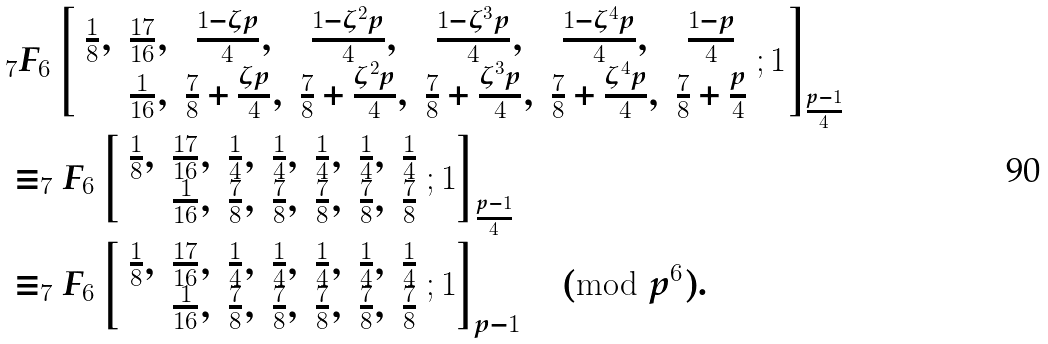Convert formula to latex. <formula><loc_0><loc_0><loc_500><loc_500>& { _ { 7 } } F _ { 6 } \left [ \begin{array} { c c c c c c c } \frac { 1 } { 8 } , & \frac { 1 7 } { 1 6 } , & \frac { 1 - \zeta p } { 4 } , & \frac { 1 - \zeta ^ { 2 } p } { 4 } , & \frac { 1 - \zeta ^ { 3 } p } { 4 } , & \frac { 1 - \zeta ^ { 4 } p } { 4 } , & \frac { 1 - p } { 4 } \\ & \frac { 1 } { 1 6 } , & \frac { 7 } { 8 } + \frac { \zeta p } { 4 } , & \frac { 7 } { 8 } + \frac { \zeta ^ { 2 } p } { 4 } , & \frac { 7 } { 8 } + \frac { \zeta ^ { 3 } p } { 4 } , & \frac { 7 } { 8 } + \frac { \zeta ^ { 4 } p } { 4 } , & \frac { 7 } { 8 } + \frac { p } { 4 } \end{array} ; 1 \right ] _ { \frac { p - 1 } { 4 } } \\ & \equiv _ { 7 } F _ { 6 } \left [ \begin{array} { c c c c c c c } \frac { 1 } { 8 } , & \frac { 1 7 } { 1 6 } , & \frac { 1 } { 4 } , & \frac { 1 } { 4 } , & \frac { 1 } { 4 } , & \frac { 1 } { 4 } , & \frac { 1 } { 4 } \\ & \frac { 1 } { 1 6 } , & \frac { 7 } { 8 } , & \frac { 7 } { 8 } , & \frac { 7 } { 8 } , & \frac { 7 } { 8 } , & \frac { 7 } { 8 } \end{array} ; 1 \right ] _ { \frac { p - 1 } { 4 } } \\ & \equiv _ { 7 } F _ { 6 } \left [ \begin{array} { c c c c c c c } \frac { 1 } { 8 } , & \frac { 1 7 } { 1 6 } , & \frac { 1 } { 4 } , & \frac { 1 } { 4 } , & \frac { 1 } { 4 } , & \frac { 1 } { 4 } , & \frac { 1 } { 4 } \\ & \frac { 1 } { 1 6 } , & \frac { 7 } { 8 } , & \frac { 7 } { 8 } , & \frac { 7 } { 8 } , & \frac { 7 } { 8 } , & \frac { 7 } { 8 } \end{array} ; 1 \right ] _ { p - 1 } \pmod { p ^ { 6 } } .</formula> 